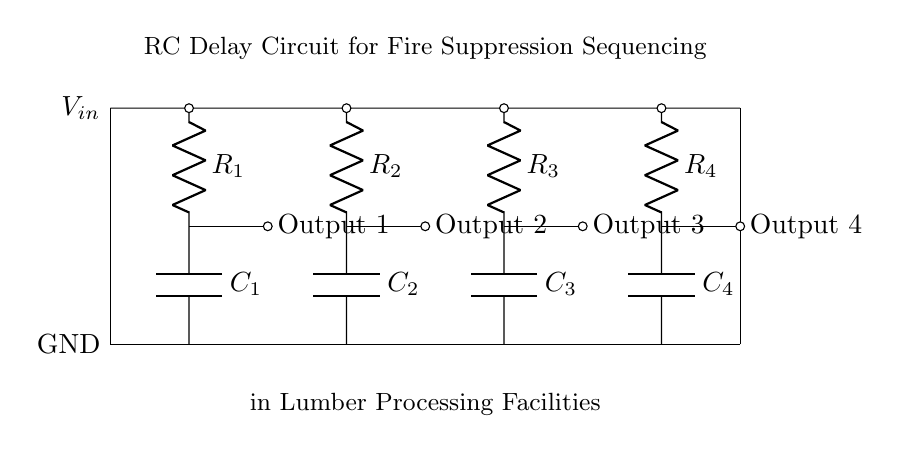What are the types of components used in this circuit? The circuit contains resistors (R) and capacitors (C). Each resistor is labeled (R1, R2, R3, R4) and each capacitor is labeled (C1, C2, C3, C4).
Answer: Resistors and capacitors What is the role of the resistors in this circuit? Resistors limit the current in the circuit and, together with capacitors, they determine the time constant for the RC delays.
Answer: Limit current and determine time constant What is the output for the first resistor-capacitor combination? The output of the first RC combination (R1 and C1) is labeled as Output 1, connected to the point where the capacitor discharges.
Answer: Output 1 How many outputs are there in this RC delay circuit? There are four outputs labeled Output 1, Output 2, Output 3, and Output 4, corresponding to each RC combination in the circuit.
Answer: Four outputs If Capacitor C1 has a capacitance of 10 microfarads and Resistor R1 has a resistance of 1 kiloohm, what is the time constant for that stage? The time constant (τ) is calculated as τ = R * C. Here, τ = 1,000 ohms * 10 * 10^-6 farads = 0.01 seconds.
Answer: 0.01 seconds What is the purpose of this RC delay circuit in relation to fire suppression? The circuit is designed to sequence fire suppression systems, ensuring that the suppression occurs in a controlled manner over time.
Answer: Sequence fire suppression systems 